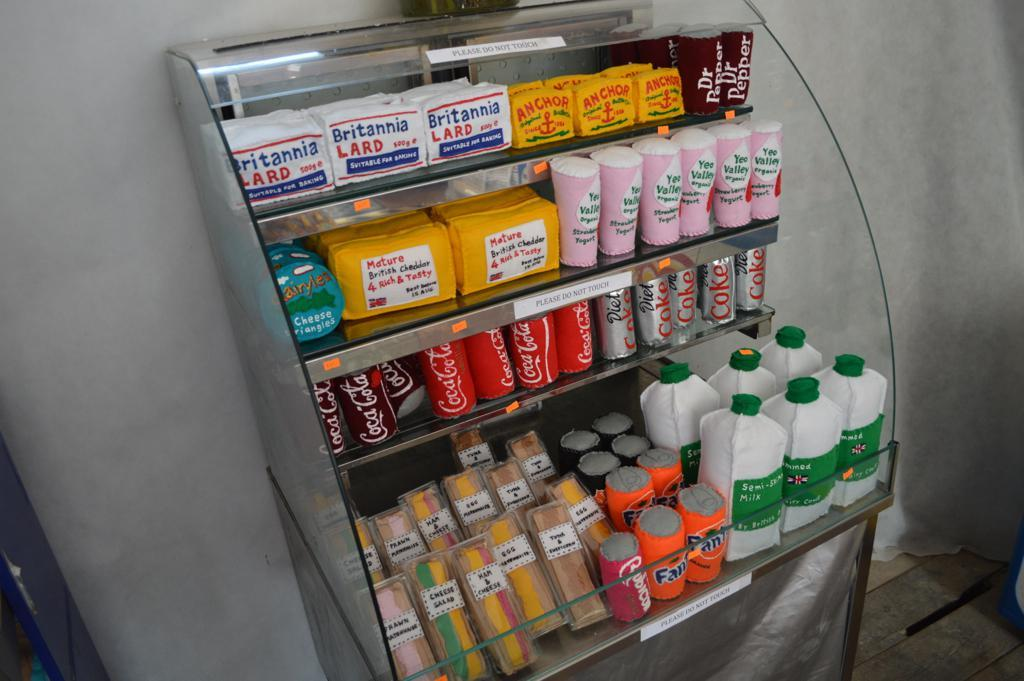Provide a one-sentence caption for the provided image. A refrigerated case features lard, drinks and sandwiches, among its wares. 